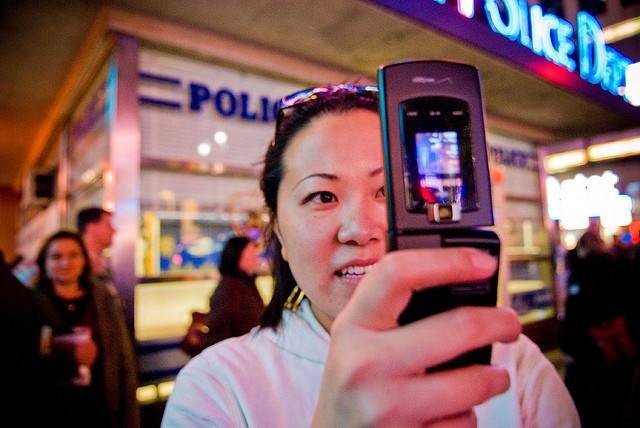Describe the objects in this image and their specific colors. I can see people in black, lightpink, salmon, brown, and darkgray tones, cell phone in black, purple, and maroon tones, people in black, maroon, and brown tones, people in black, maroon, salmon, and lavender tones, and people in black, maroon, red, and brown tones in this image. 